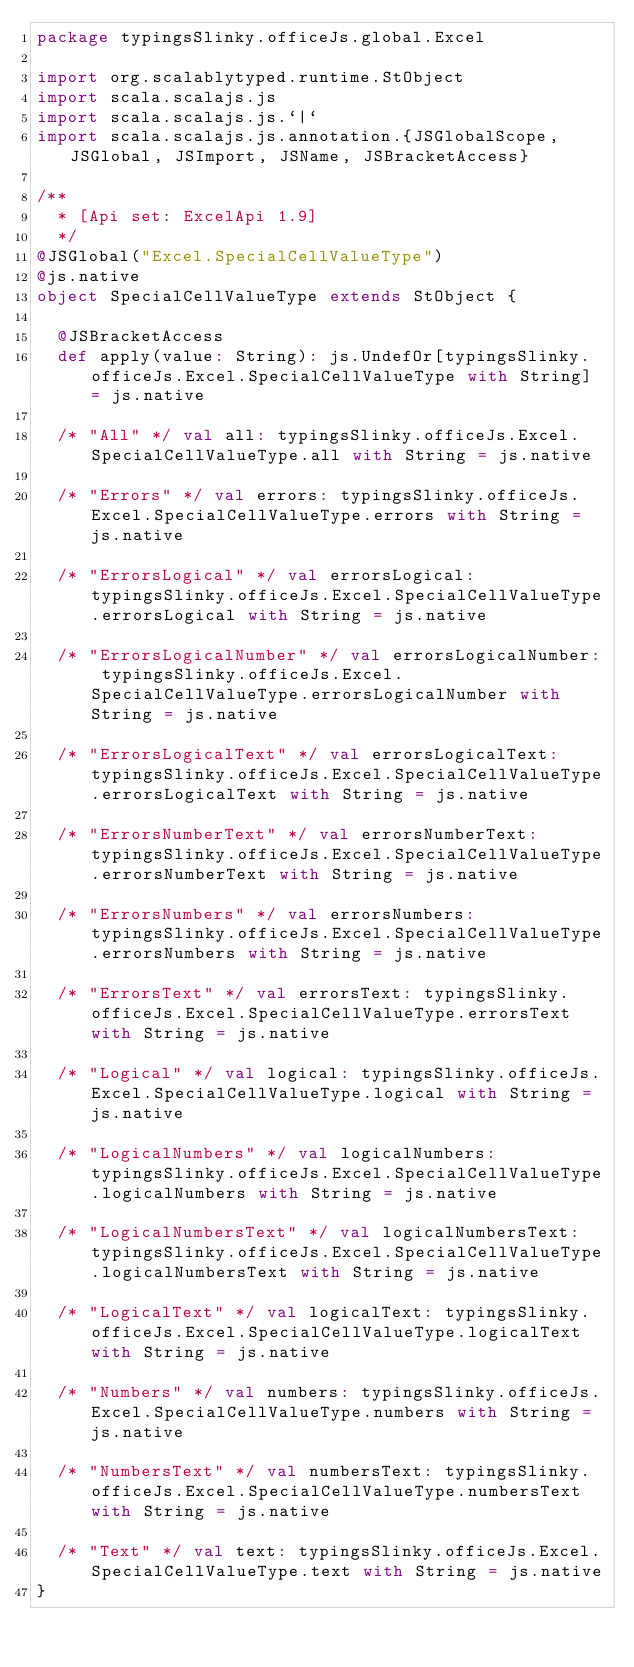<code> <loc_0><loc_0><loc_500><loc_500><_Scala_>package typingsSlinky.officeJs.global.Excel

import org.scalablytyped.runtime.StObject
import scala.scalajs.js
import scala.scalajs.js.`|`
import scala.scalajs.js.annotation.{JSGlobalScope, JSGlobal, JSImport, JSName, JSBracketAccess}

/**
  * [Api set: ExcelApi 1.9]
  */
@JSGlobal("Excel.SpecialCellValueType")
@js.native
object SpecialCellValueType extends StObject {
  
  @JSBracketAccess
  def apply(value: String): js.UndefOr[typingsSlinky.officeJs.Excel.SpecialCellValueType with String] = js.native
  
  /* "All" */ val all: typingsSlinky.officeJs.Excel.SpecialCellValueType.all with String = js.native
  
  /* "Errors" */ val errors: typingsSlinky.officeJs.Excel.SpecialCellValueType.errors with String = js.native
  
  /* "ErrorsLogical" */ val errorsLogical: typingsSlinky.officeJs.Excel.SpecialCellValueType.errorsLogical with String = js.native
  
  /* "ErrorsLogicalNumber" */ val errorsLogicalNumber: typingsSlinky.officeJs.Excel.SpecialCellValueType.errorsLogicalNumber with String = js.native
  
  /* "ErrorsLogicalText" */ val errorsLogicalText: typingsSlinky.officeJs.Excel.SpecialCellValueType.errorsLogicalText with String = js.native
  
  /* "ErrorsNumberText" */ val errorsNumberText: typingsSlinky.officeJs.Excel.SpecialCellValueType.errorsNumberText with String = js.native
  
  /* "ErrorsNumbers" */ val errorsNumbers: typingsSlinky.officeJs.Excel.SpecialCellValueType.errorsNumbers with String = js.native
  
  /* "ErrorsText" */ val errorsText: typingsSlinky.officeJs.Excel.SpecialCellValueType.errorsText with String = js.native
  
  /* "Logical" */ val logical: typingsSlinky.officeJs.Excel.SpecialCellValueType.logical with String = js.native
  
  /* "LogicalNumbers" */ val logicalNumbers: typingsSlinky.officeJs.Excel.SpecialCellValueType.logicalNumbers with String = js.native
  
  /* "LogicalNumbersText" */ val logicalNumbersText: typingsSlinky.officeJs.Excel.SpecialCellValueType.logicalNumbersText with String = js.native
  
  /* "LogicalText" */ val logicalText: typingsSlinky.officeJs.Excel.SpecialCellValueType.logicalText with String = js.native
  
  /* "Numbers" */ val numbers: typingsSlinky.officeJs.Excel.SpecialCellValueType.numbers with String = js.native
  
  /* "NumbersText" */ val numbersText: typingsSlinky.officeJs.Excel.SpecialCellValueType.numbersText with String = js.native
  
  /* "Text" */ val text: typingsSlinky.officeJs.Excel.SpecialCellValueType.text with String = js.native
}
</code> 